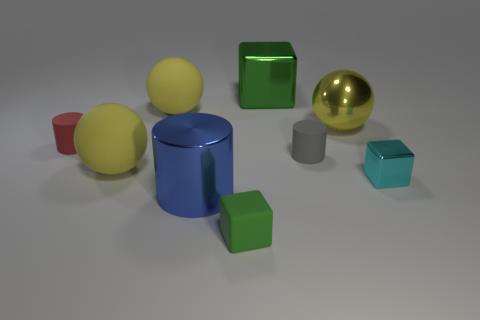There is another small thing that is the same shape as the tiny red rubber thing; what is its material?
Give a very brief answer. Rubber. There is a tiny object that is the same color as the big cube; what material is it?
Provide a succinct answer. Rubber. Are there fewer small blocks than tiny gray objects?
Provide a succinct answer. No. Do the cube in front of the small shiny cube and the big block have the same color?
Your response must be concise. Yes. There is a small cube that is made of the same material as the big green thing; what color is it?
Your response must be concise. Cyan. Is the size of the blue object the same as the metallic sphere?
Keep it short and to the point. Yes. What is the big green thing made of?
Ensure brevity in your answer.  Metal. There is a red cylinder that is the same size as the cyan cube; what is it made of?
Your response must be concise. Rubber. Are there any yellow shiny balls that have the same size as the green metallic object?
Provide a short and direct response. Yes. Are there an equal number of big spheres on the right side of the small gray cylinder and tiny gray rubber objects that are on the left side of the tiny metallic thing?
Your answer should be very brief. Yes. 